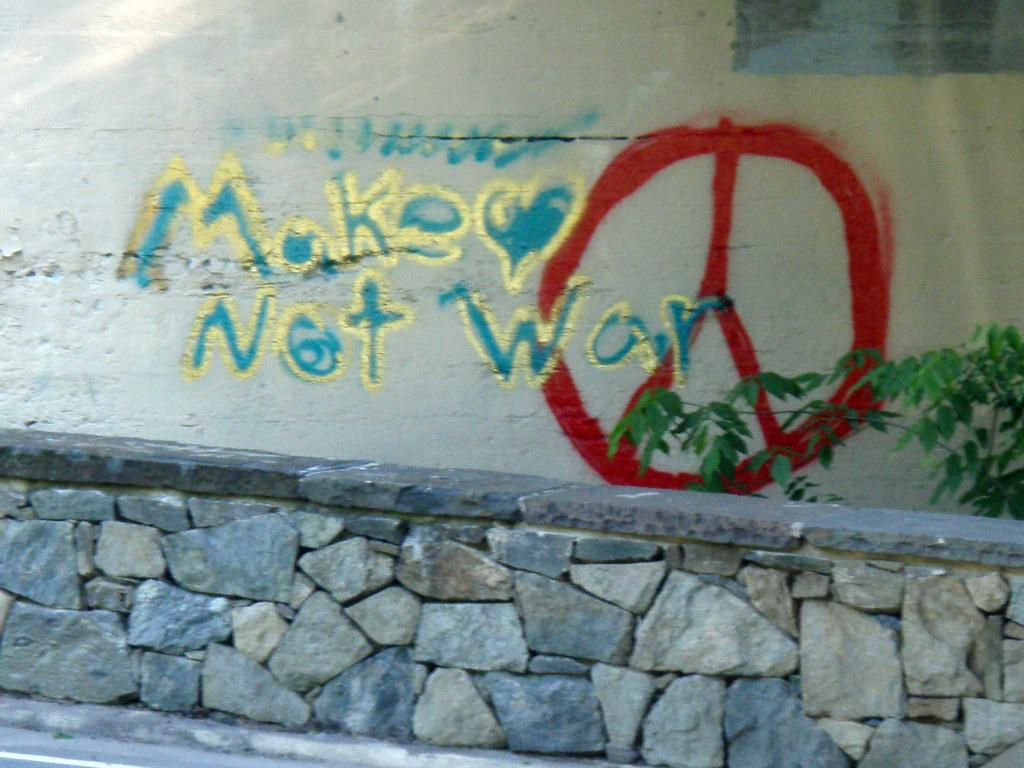What is located in the foreground of the image? There is a stone seating wall in the foreground of the image. What can be seen on a wall in the background of the image? There is text visible on a wall in the background of the image, and there is also some drawing on the wall. Where is the plant located in the image? The plant is in the right corner of the image. What type of pie is being served on the seating wall in the image? There is no pie present in the image; it features a stone seating wall, text and drawing on a wall in the background, and a plant in the right corner. How many cents are visible on the seating wall in the image? There are no cents visible on the seating wall or anywhere else in the image. 